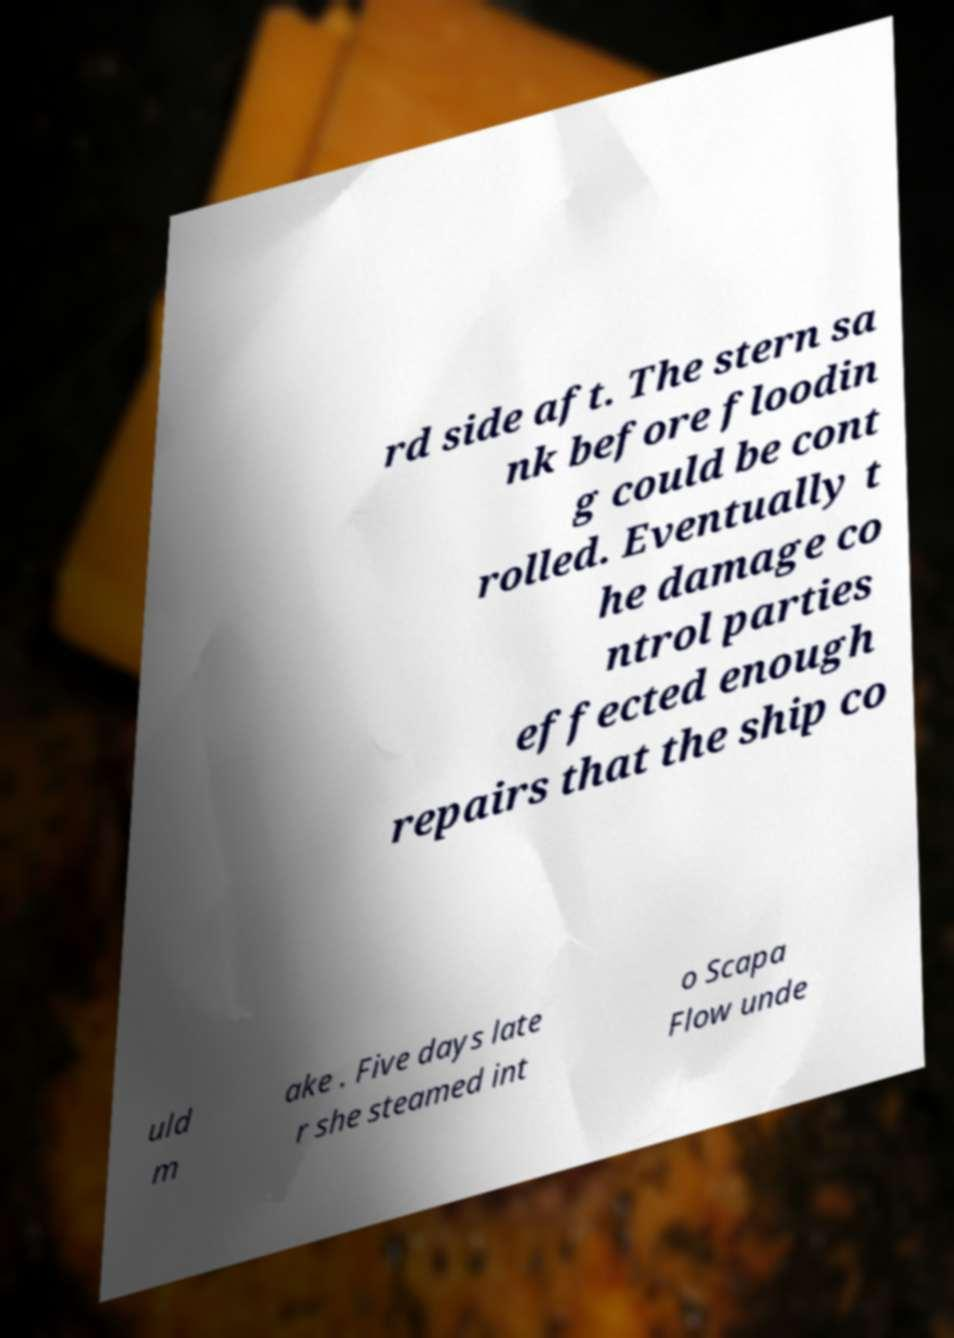For documentation purposes, I need the text within this image transcribed. Could you provide that? rd side aft. The stern sa nk before floodin g could be cont rolled. Eventually t he damage co ntrol parties effected enough repairs that the ship co uld m ake . Five days late r she steamed int o Scapa Flow unde 